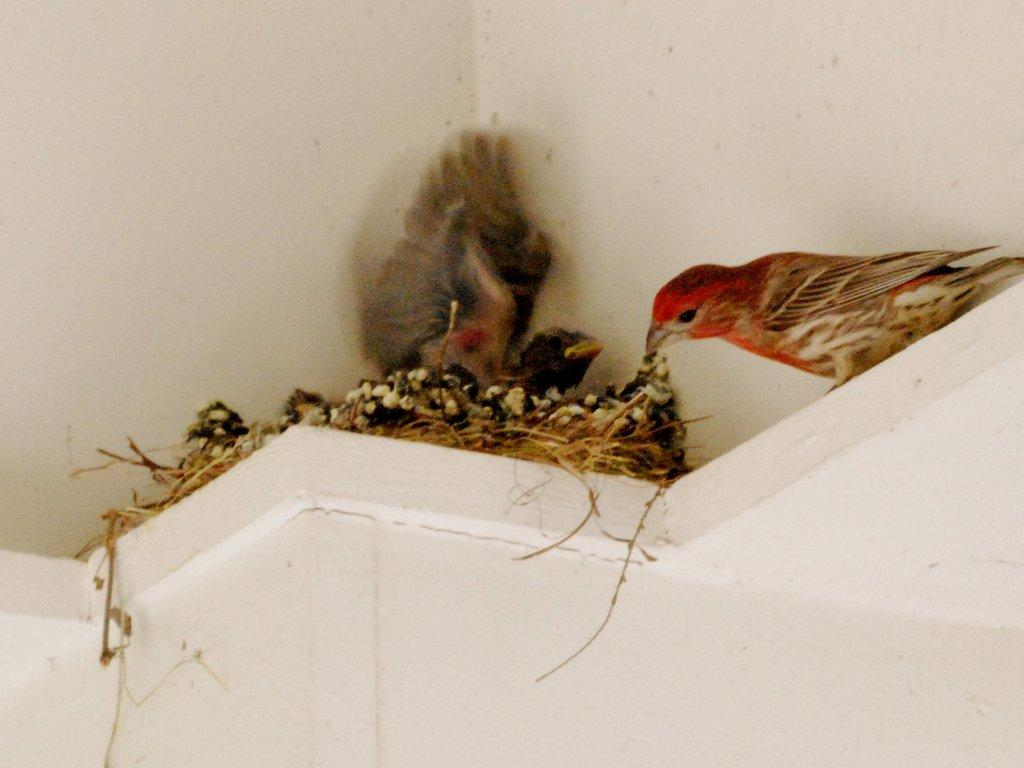What type of animal can be seen in the image? There is a bird in the image. Where is the bird located? The bird is nesting on top of a wall. What type of cakes are being served at the thrilling event in the image? There are no cakes or events present in the image; it only features a bird nesting on a wall. 